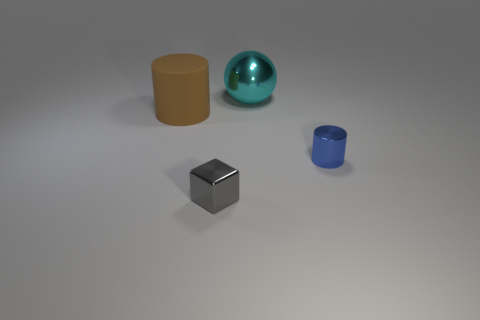Add 3 large shiny balls. How many objects exist? 7 Subtract all blocks. How many objects are left? 3 Add 1 big cyan cylinders. How many big cyan cylinders exist? 1 Subtract 0 red balls. How many objects are left? 4 Subtract all tiny cubes. Subtract all big brown matte cylinders. How many objects are left? 2 Add 2 cyan spheres. How many cyan spheres are left? 3 